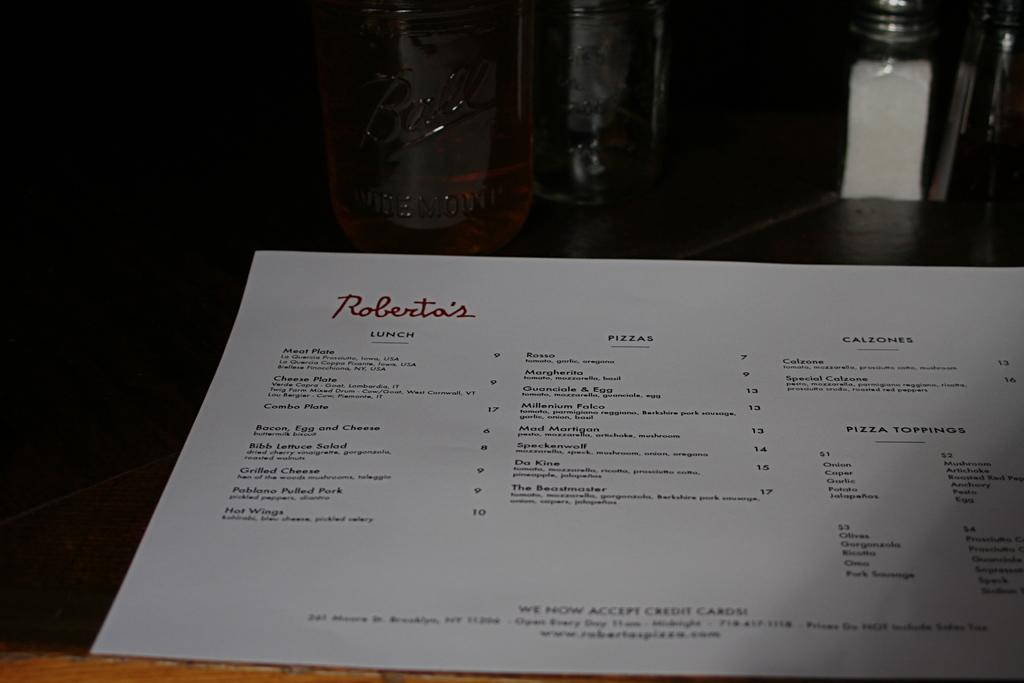<image>
Give a short and clear explanation of the subsequent image. Roberta's offer a lunch menu including hot wings and grilled cheese. 